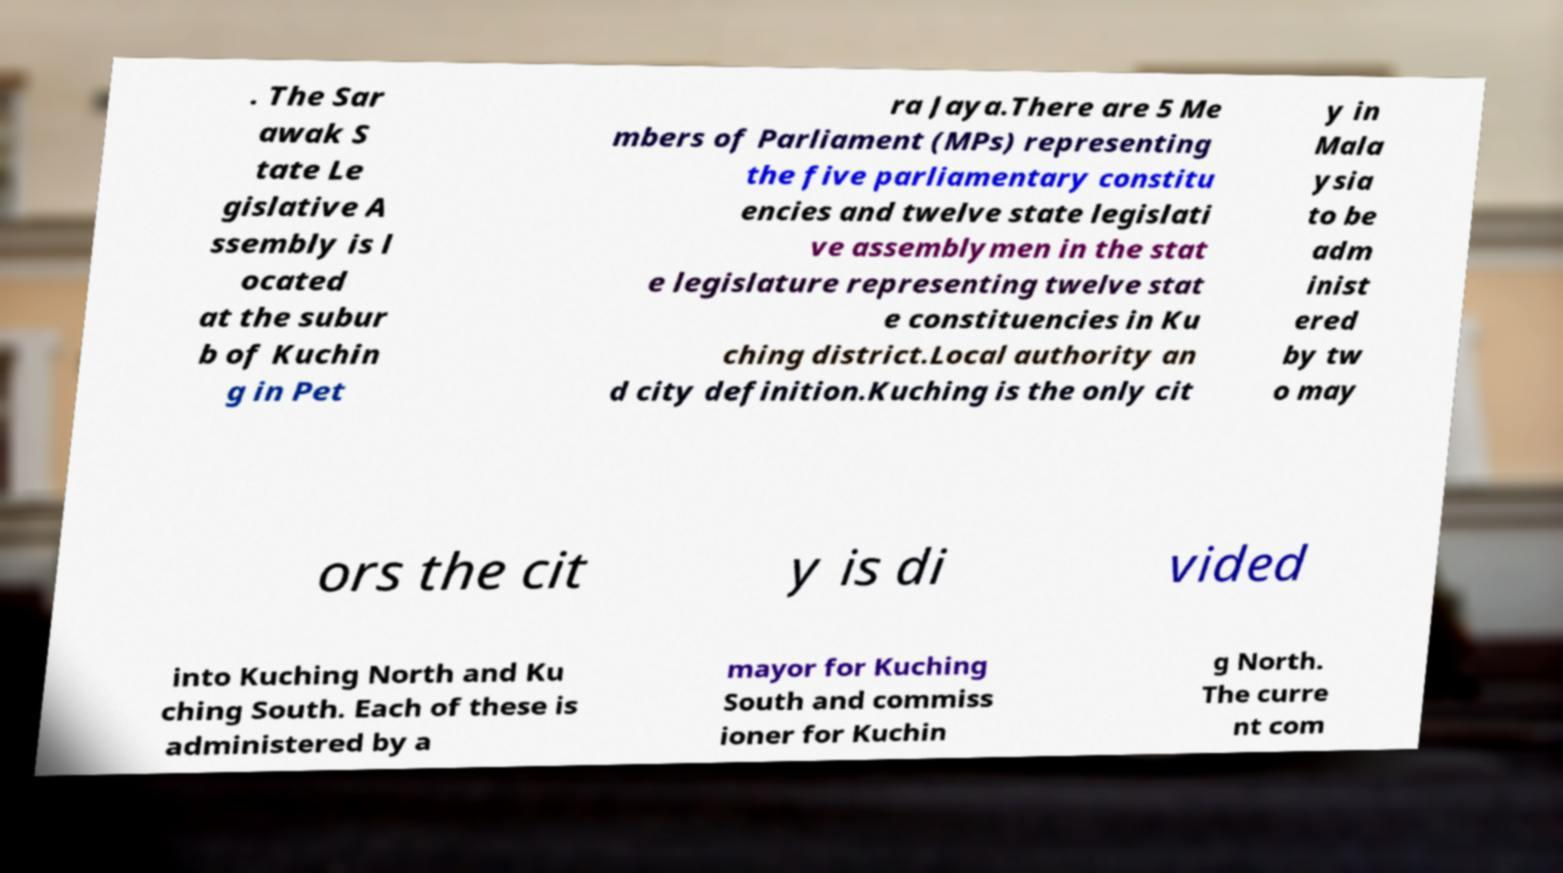Can you accurately transcribe the text from the provided image for me? . The Sar awak S tate Le gislative A ssembly is l ocated at the subur b of Kuchin g in Pet ra Jaya.There are 5 Me mbers of Parliament (MPs) representing the five parliamentary constitu encies and twelve state legislati ve assemblymen in the stat e legislature representing twelve stat e constituencies in Ku ching district.Local authority an d city definition.Kuching is the only cit y in Mala ysia to be adm inist ered by tw o may ors the cit y is di vided into Kuching North and Ku ching South. Each of these is administered by a mayor for Kuching South and commiss ioner for Kuchin g North. The curre nt com 